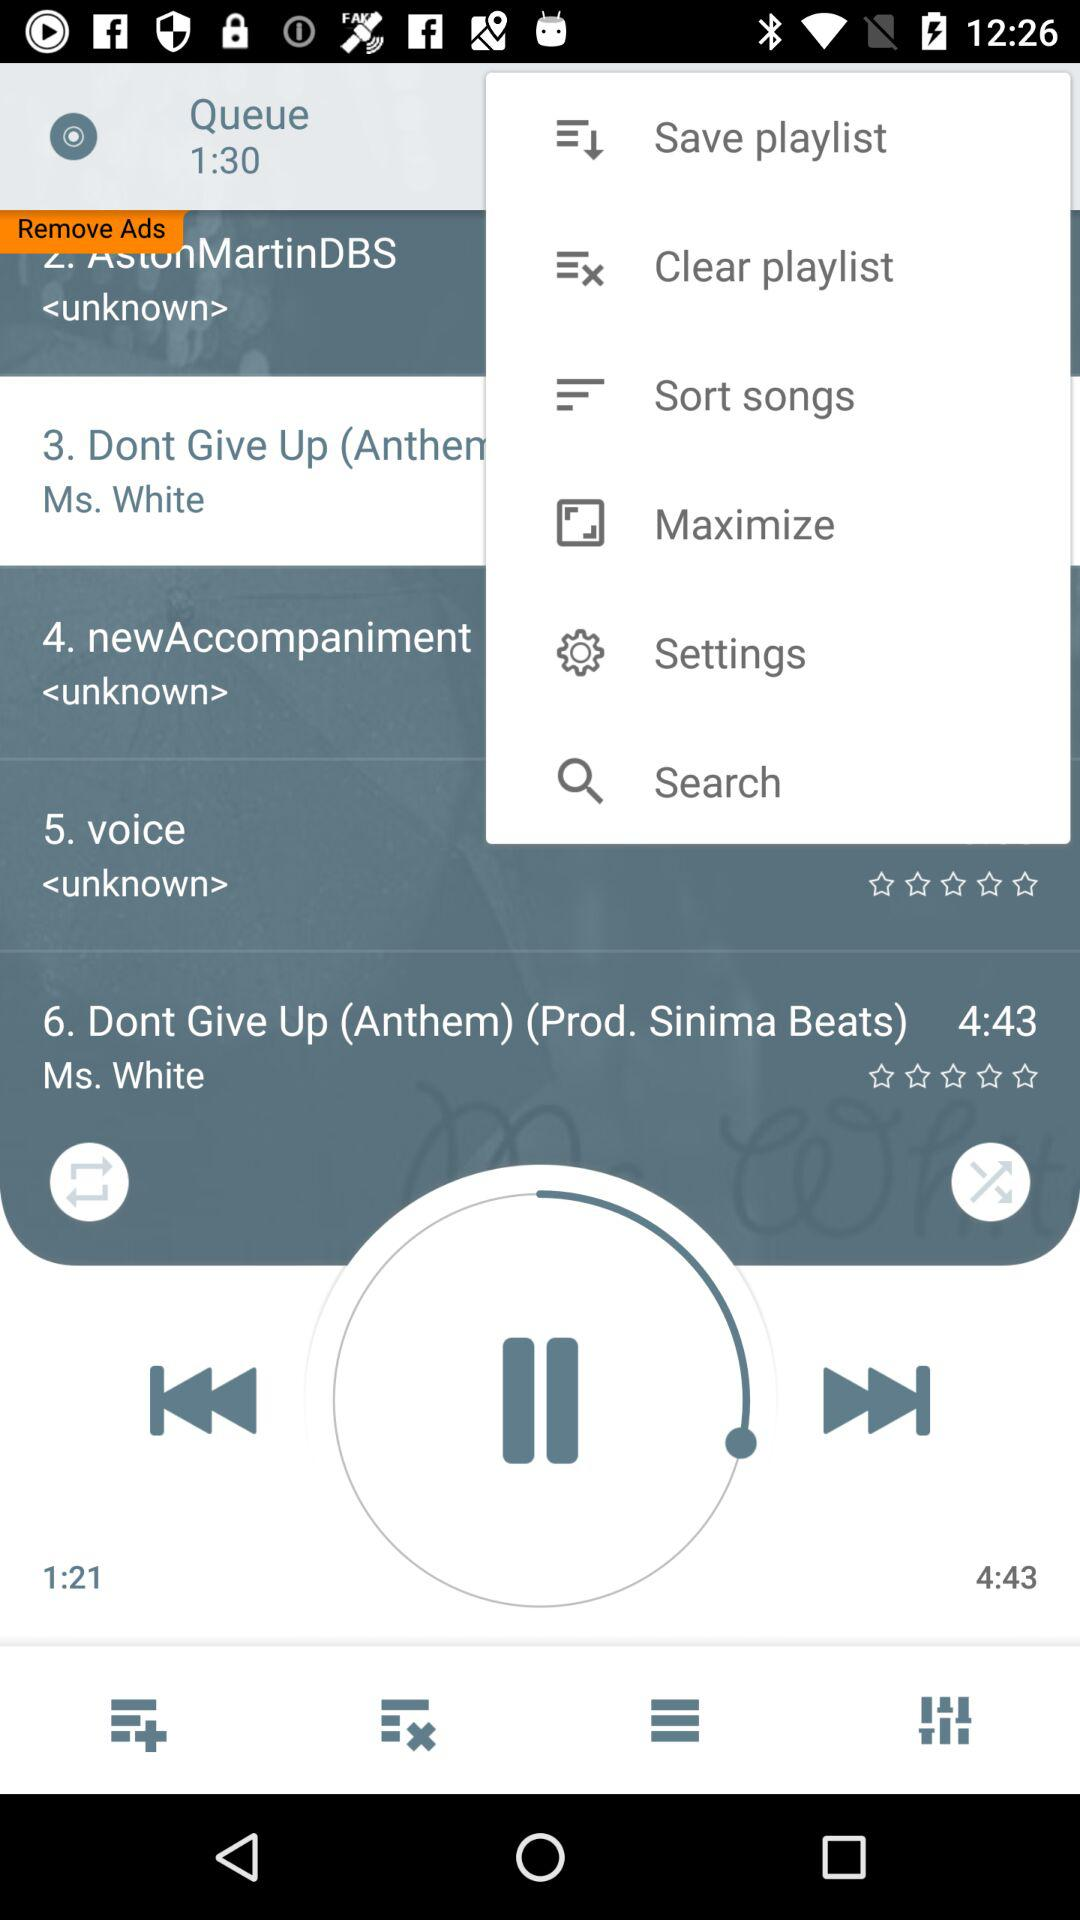What is the total length of the current playing audio? The total length of the current playing audio is 4 minutes 43 seconds. 